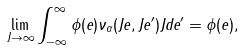<formula> <loc_0><loc_0><loc_500><loc_500>\lim _ { J \rightarrow \infty } \int _ { - \infty } ^ { \infty } \phi ( e ) \nu _ { \alpha } ( J e , J e ^ { \prime } ) J d e ^ { \prime } = \phi ( e ) ,</formula> 